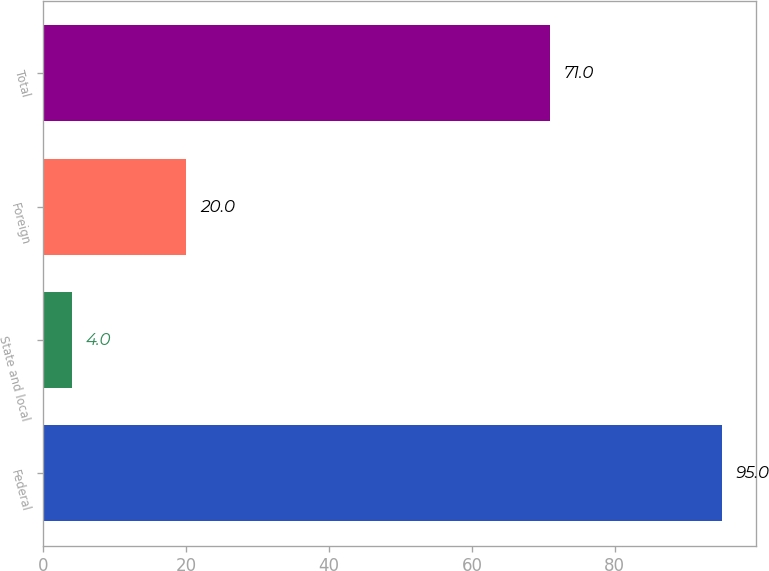<chart> <loc_0><loc_0><loc_500><loc_500><bar_chart><fcel>Federal<fcel>State and local<fcel>Foreign<fcel>Total<nl><fcel>95<fcel>4<fcel>20<fcel>71<nl></chart> 